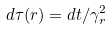<formula> <loc_0><loc_0><loc_500><loc_500>d \tau ( r ) = d t / \gamma _ { r } ^ { 2 }</formula> 